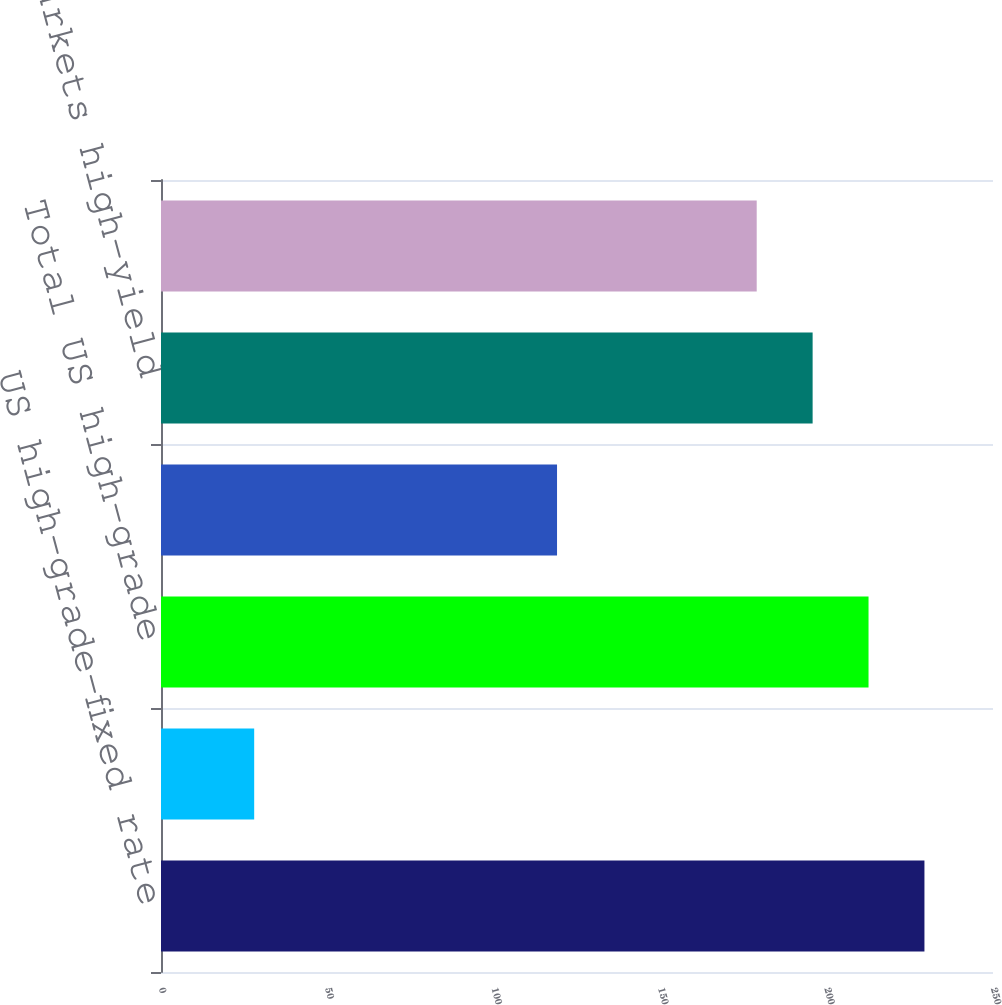Convert chart. <chart><loc_0><loc_0><loc_500><loc_500><bar_chart><fcel>US high-grade-fixed rate<fcel>US high-grade-floating rate<fcel>Total US high-grade<fcel>Eurobond<fcel>Emerging markets high-yield<fcel>Total<nl><fcel>229.4<fcel>28<fcel>212.6<fcel>119<fcel>195.8<fcel>179<nl></chart> 